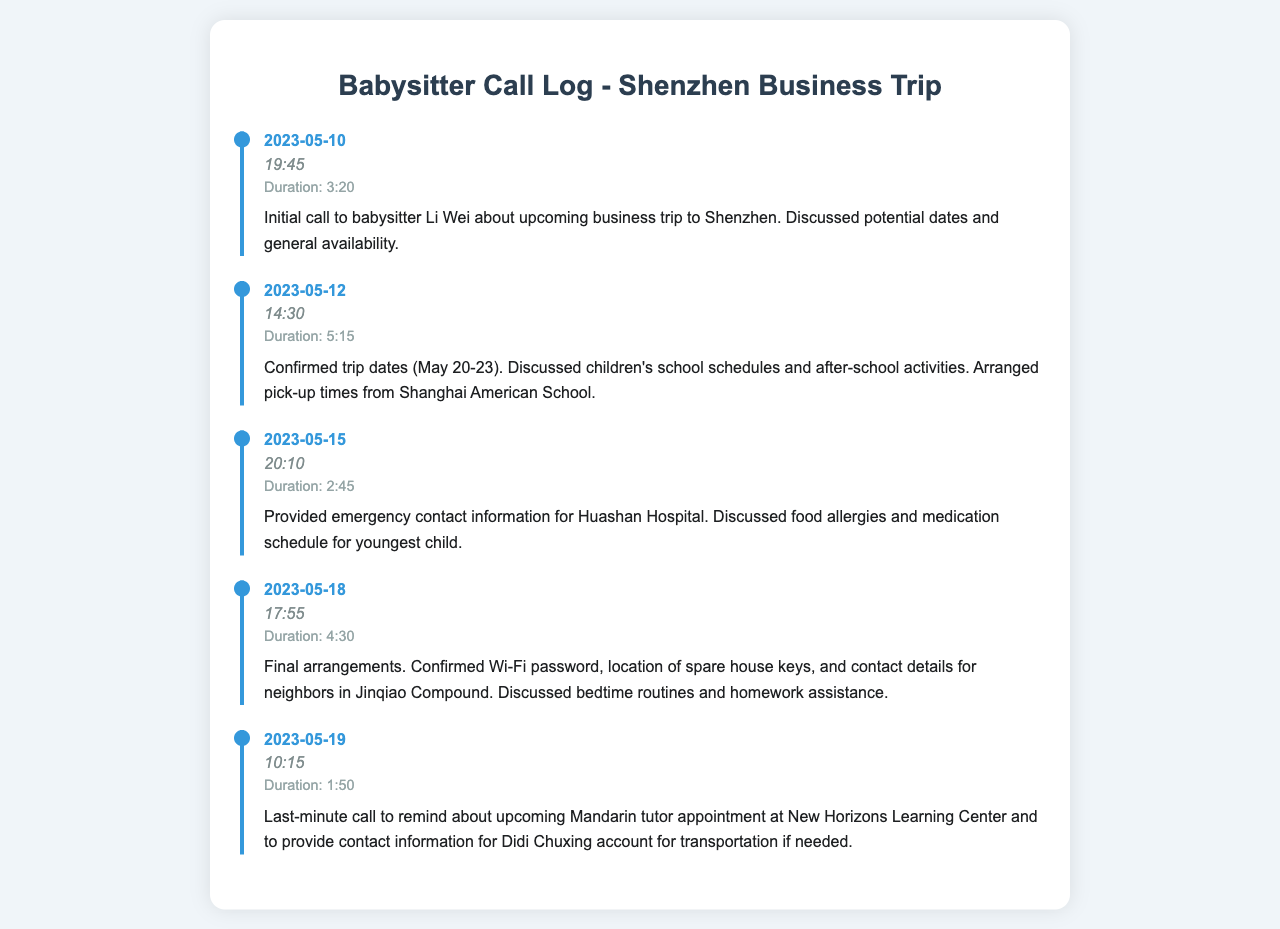What is the date of the first call? The first call took place on 2023-05-10, as noted in the call log.
Answer: 2023-05-10 How long was the second call? The duration of the second call is provided as 5:15, which is stated in the call log details.
Answer: 5:15 Who is the babysitter's name? The babysitter's name is mentioned in the first call summary, identifying her as Li Wei.
Answer: Li Wei What are the confirmed trip dates? The confirmed trip dates are explicitly stated during the second call, which is from May 20-23.
Answer: May 20-23 Which hospital's emergency contact information was provided? The emergency contact information for Huashan Hospital is given during the third call.
Answer: Huashan Hospital How many total calls are recorded? The document lists a total of five calls made to the babysitter for the arrangement.
Answer: 5 What was discussed in the final call? The final call summary includes reminders about the Mandarin tutor appointment and transportation contact information.
Answer: Mandarin tutor appointment and transportation contact What was confirmed during the final arrangements? The final arrangements included confirming the Wi-Fi password and the location of spare house keys.
Answer: Wi-Fi password and spare house keys What is the time of the last call? The last call occurred at 10:15, as noted in the call log.
Answer: 10:15 